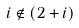Convert formula to latex. <formula><loc_0><loc_0><loc_500><loc_500>i \notin ( 2 + i )</formula> 